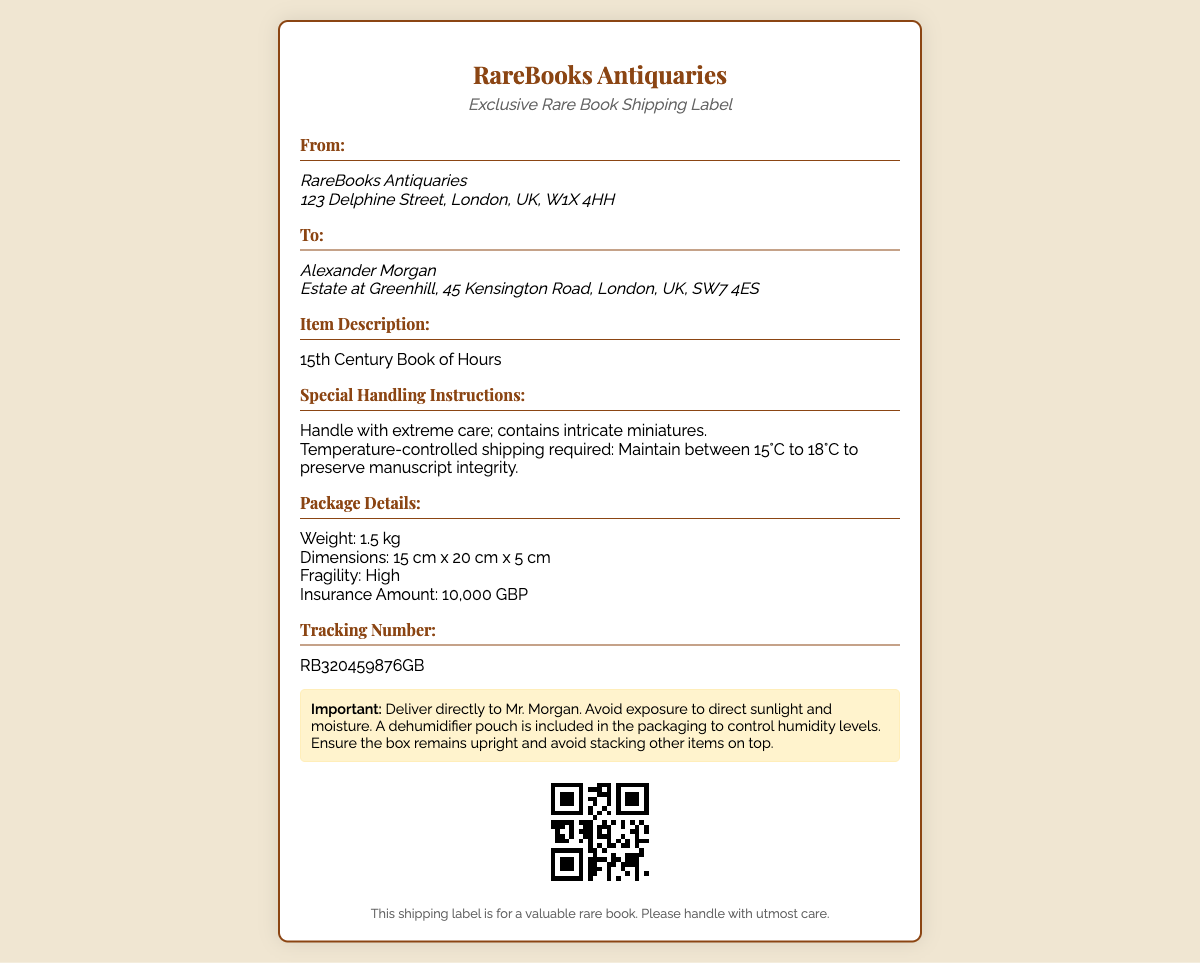What is the title of the item being shipped? The title of the item is specified in the "Item Description" section of the label, which states that it is a "15th Century Book of Hours."
Answer: 15th Century Book of Hours Who is the recipient of the shipment? The destination address indicates the recipient's name located in the "To" section, which is "Alexander Morgan."
Answer: Alexander Morgan What city is the sender located in? The sender's address indicates their location, specifically the city mentioned in the "From" section, which is "London."
Answer: London What is the insurance amount for this shipment? The insurance amount can be found in the "Package Details" section, which states an amount of "10,000 GBP."
Answer: 10,000 GBP What temperature range is required for shipping? The temperature control requirements are in the "Special Handling Instructions" section, stating, "Maintain between 15°C to 18°C."
Answer: 15°C to 18°C What is the total weight of the package? The weight of the package is specified in the "Package Details" section, which states "1.5 kg."
Answer: 1.5 kg What is the tracking number for this shipment? The tracking number can be found in the "Tracking Number" section, which is "RB320459876GB."
Answer: RB320459876GB What is noted about the fragility of the item? The fragility of the item is indicated in the "Package Details" section, which states "High."
Answer: High What should be included to control humidity levels? The label contains a note in the warnings about humidity, stating that "A dehumidifier pouch is included."
Answer: A dehumidifier pouch 